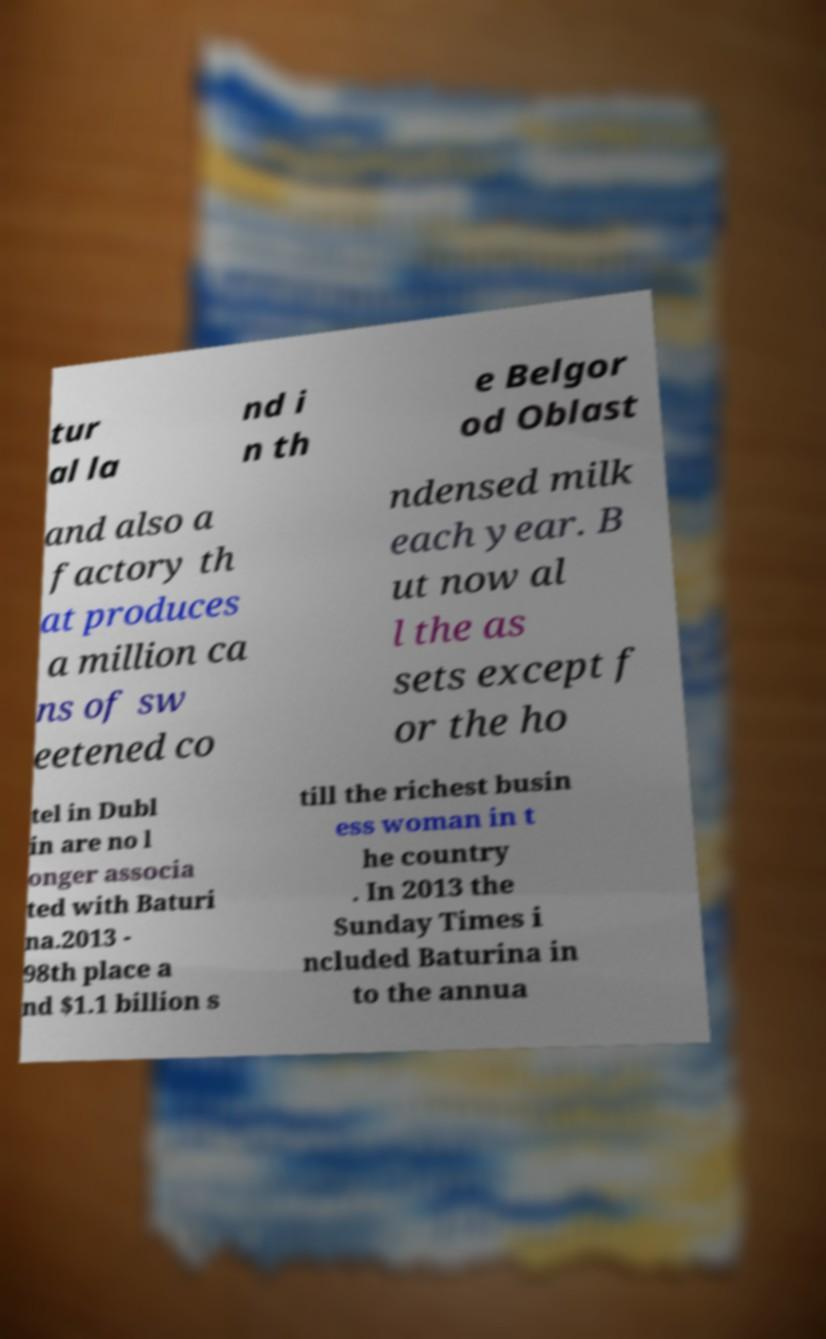For documentation purposes, I need the text within this image transcribed. Could you provide that? tur al la nd i n th e Belgor od Oblast and also a factory th at produces a million ca ns of sw eetened co ndensed milk each year. B ut now al l the as sets except f or the ho tel in Dubl in are no l onger associa ted with Baturi na.2013 - 98th place a nd $1.1 billion s till the richest busin ess woman in t he country . In 2013 the Sunday Times i ncluded Baturina in to the annua 